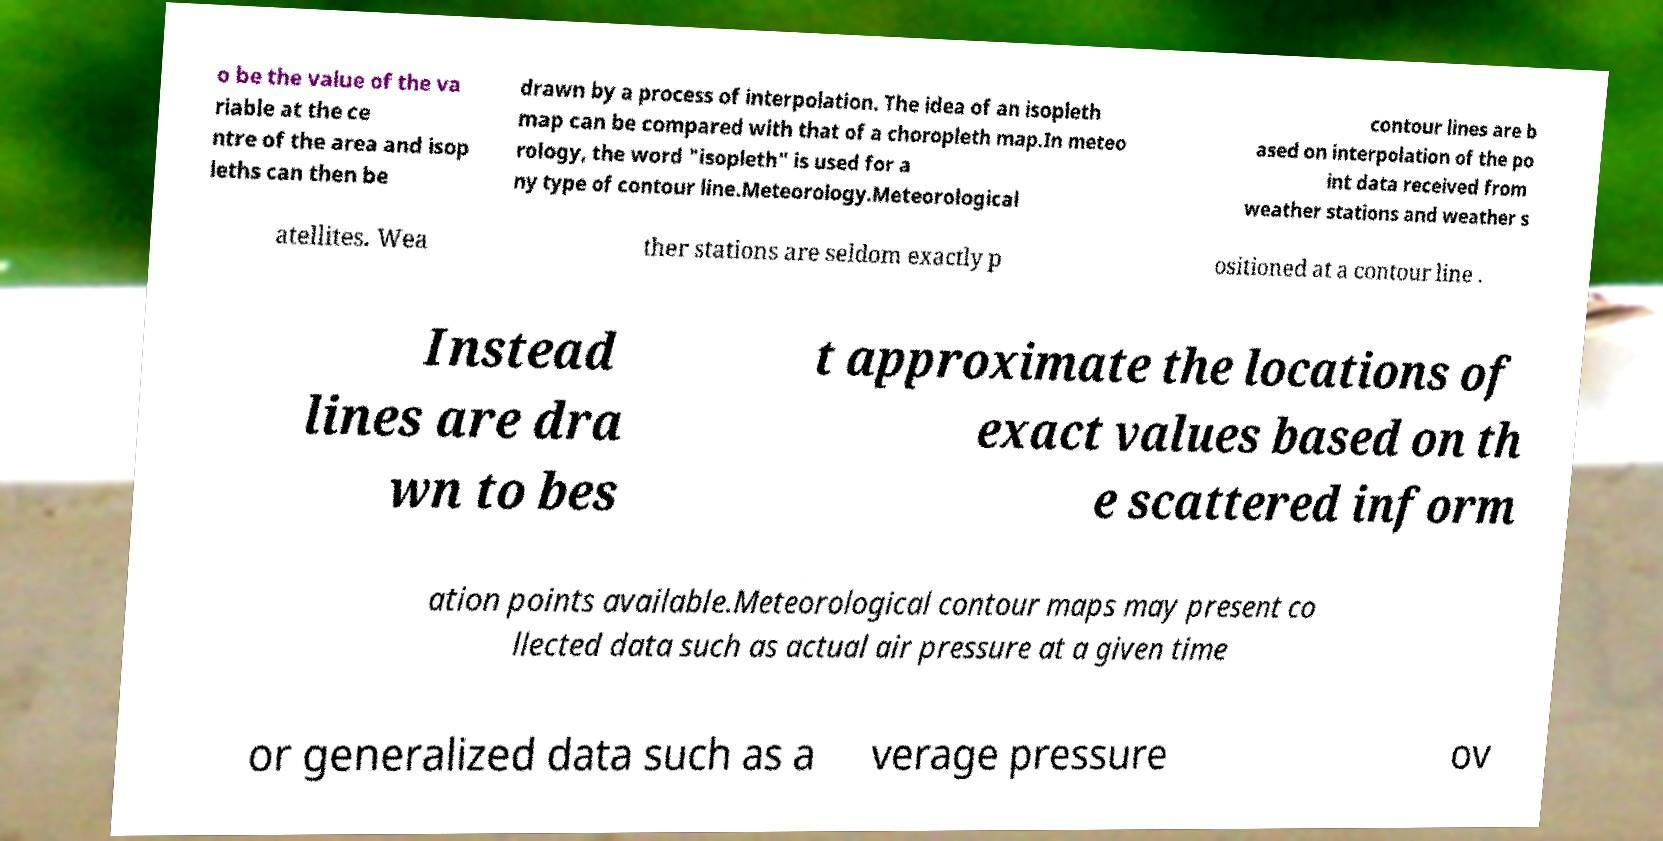Could you assist in decoding the text presented in this image and type it out clearly? o be the value of the va riable at the ce ntre of the area and isop leths can then be drawn by a process of interpolation. The idea of an isopleth map can be compared with that of a choropleth map.In meteo rology, the word "isopleth" is used for a ny type of contour line.Meteorology.Meteorological contour lines are b ased on interpolation of the po int data received from weather stations and weather s atellites. Wea ther stations are seldom exactly p ositioned at a contour line . Instead lines are dra wn to bes t approximate the locations of exact values based on th e scattered inform ation points available.Meteorological contour maps may present co llected data such as actual air pressure at a given time or generalized data such as a verage pressure ov 